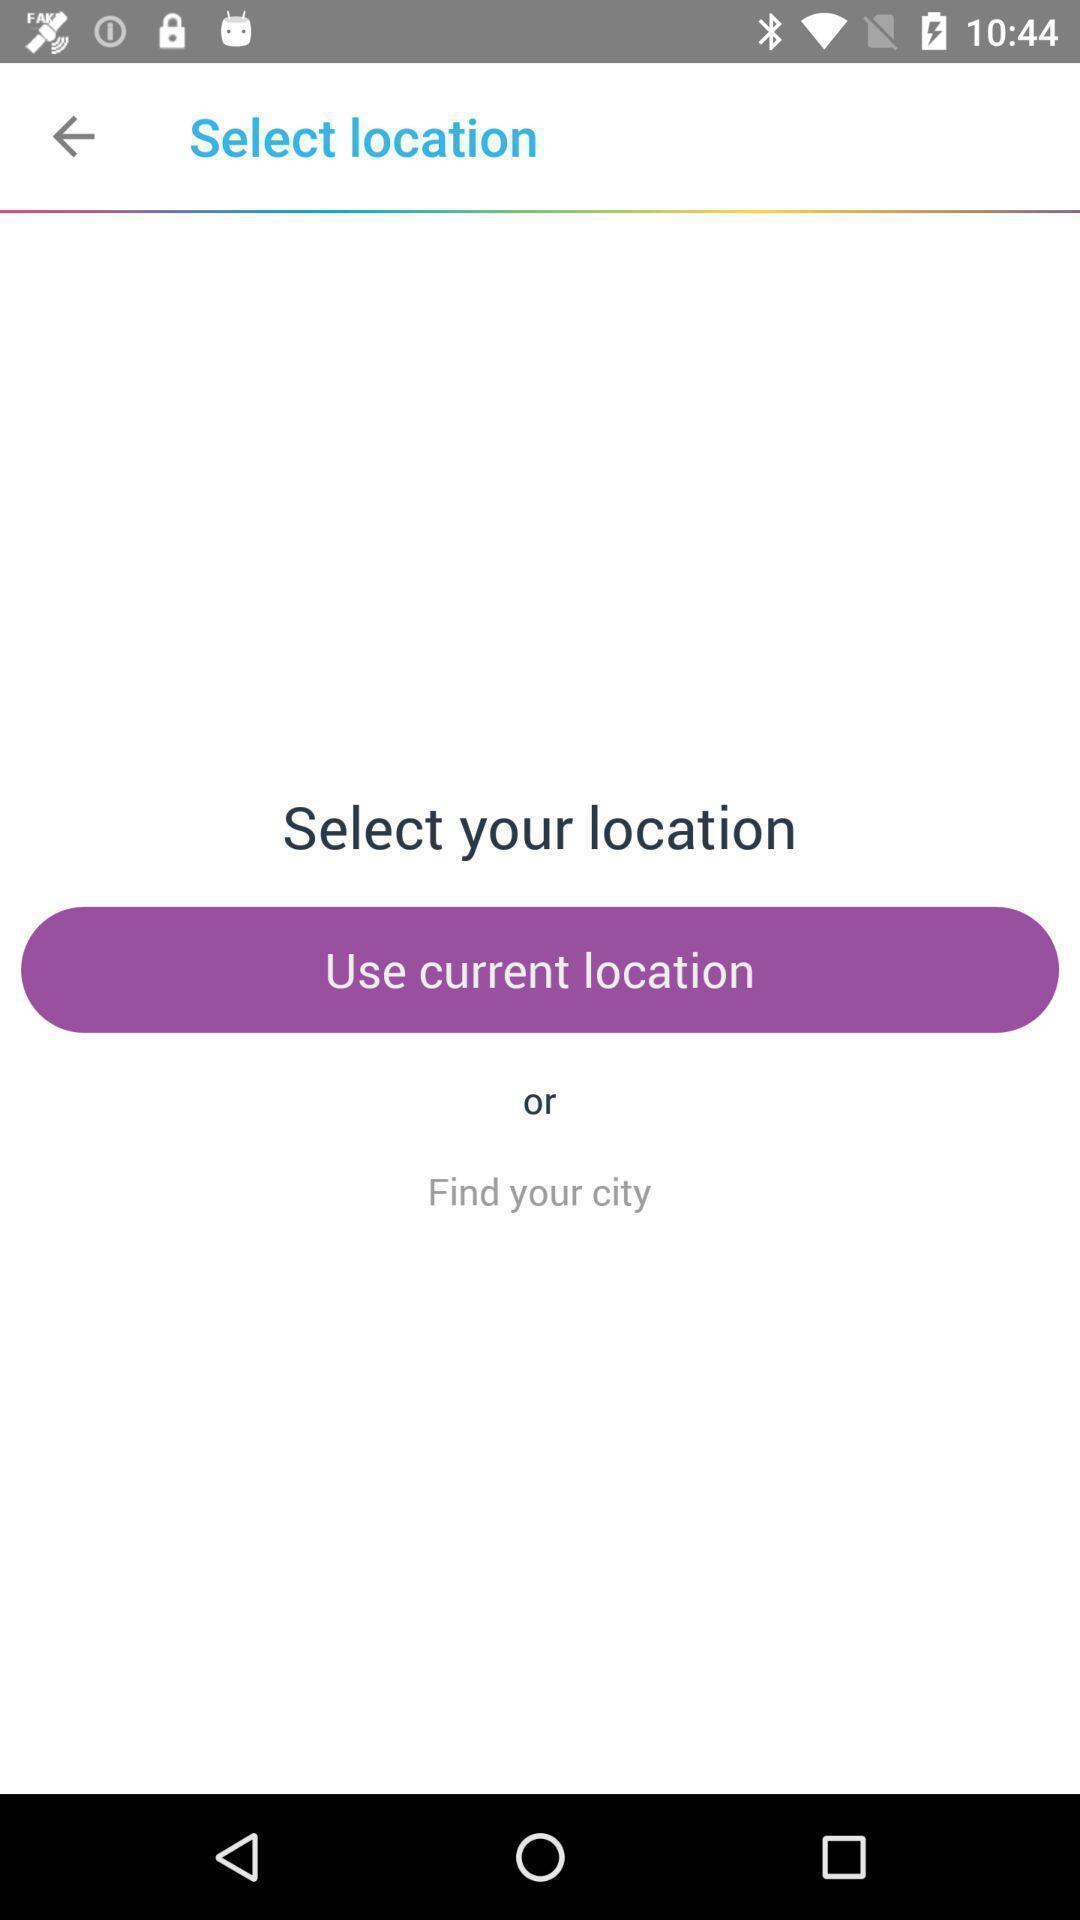Explain the elements present in this screenshot. Page displaying to select location services. 